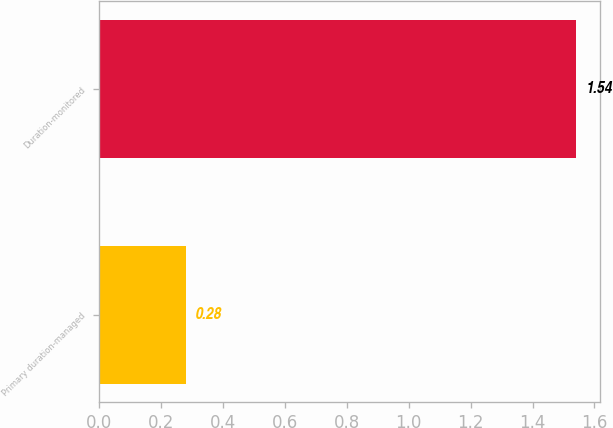Convert chart. <chart><loc_0><loc_0><loc_500><loc_500><bar_chart><fcel>Primary duration-managed<fcel>Duration-monitored<nl><fcel>0.28<fcel>1.54<nl></chart> 